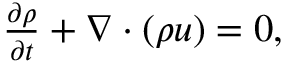<formula> <loc_0><loc_0><loc_500><loc_500>\begin{array} { r } { \frac { \partial \rho } { \partial t } + \nabla \cdot ( \rho u ) = 0 , } \end{array}</formula> 